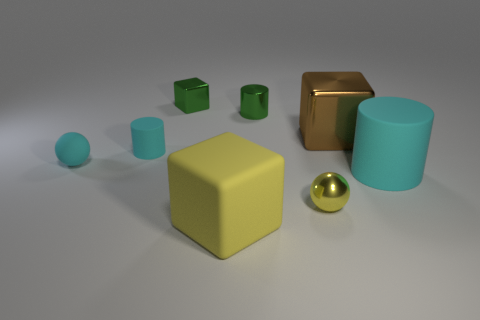What is the material of the tiny cylinder that is the same color as the tiny cube?
Make the answer very short. Metal. There is a ball right of the cyan rubber sphere; what material is it?
Offer a terse response. Metal. Are there any yellow rubber blocks behind the large cyan cylinder?
Offer a terse response. No. What is the shape of the yellow rubber thing?
Offer a very short reply. Cube. What number of objects are spheres in front of the cyan sphere or large matte objects?
Provide a short and direct response. 3. How many other objects are there of the same color as the rubber sphere?
Offer a terse response. 2. There is a tiny rubber cylinder; is it the same color as the rubber thing to the left of the small rubber cylinder?
Offer a terse response. Yes. What color is the rubber object that is the same shape as the big metal object?
Your answer should be very brief. Yellow. Is the material of the brown object the same as the sphere on the right side of the large yellow rubber block?
Offer a very short reply. Yes. What color is the large cylinder?
Your answer should be very brief. Cyan. 